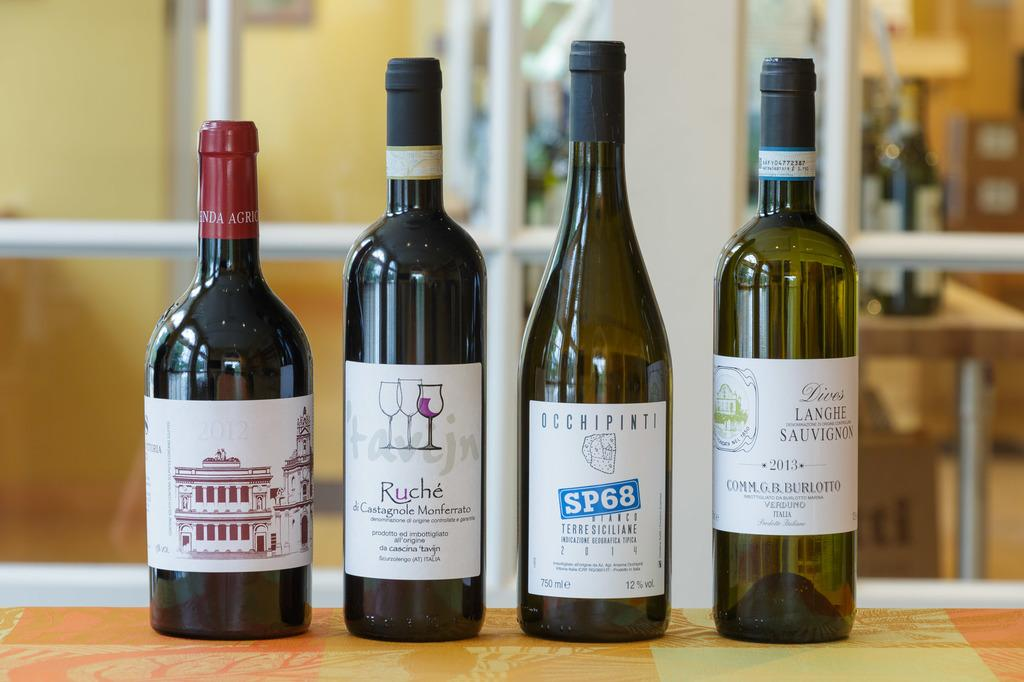<image>
Share a concise interpretation of the image provided. A bottle of wine that says SP68 on the label sits with a few other bottles in a row. 